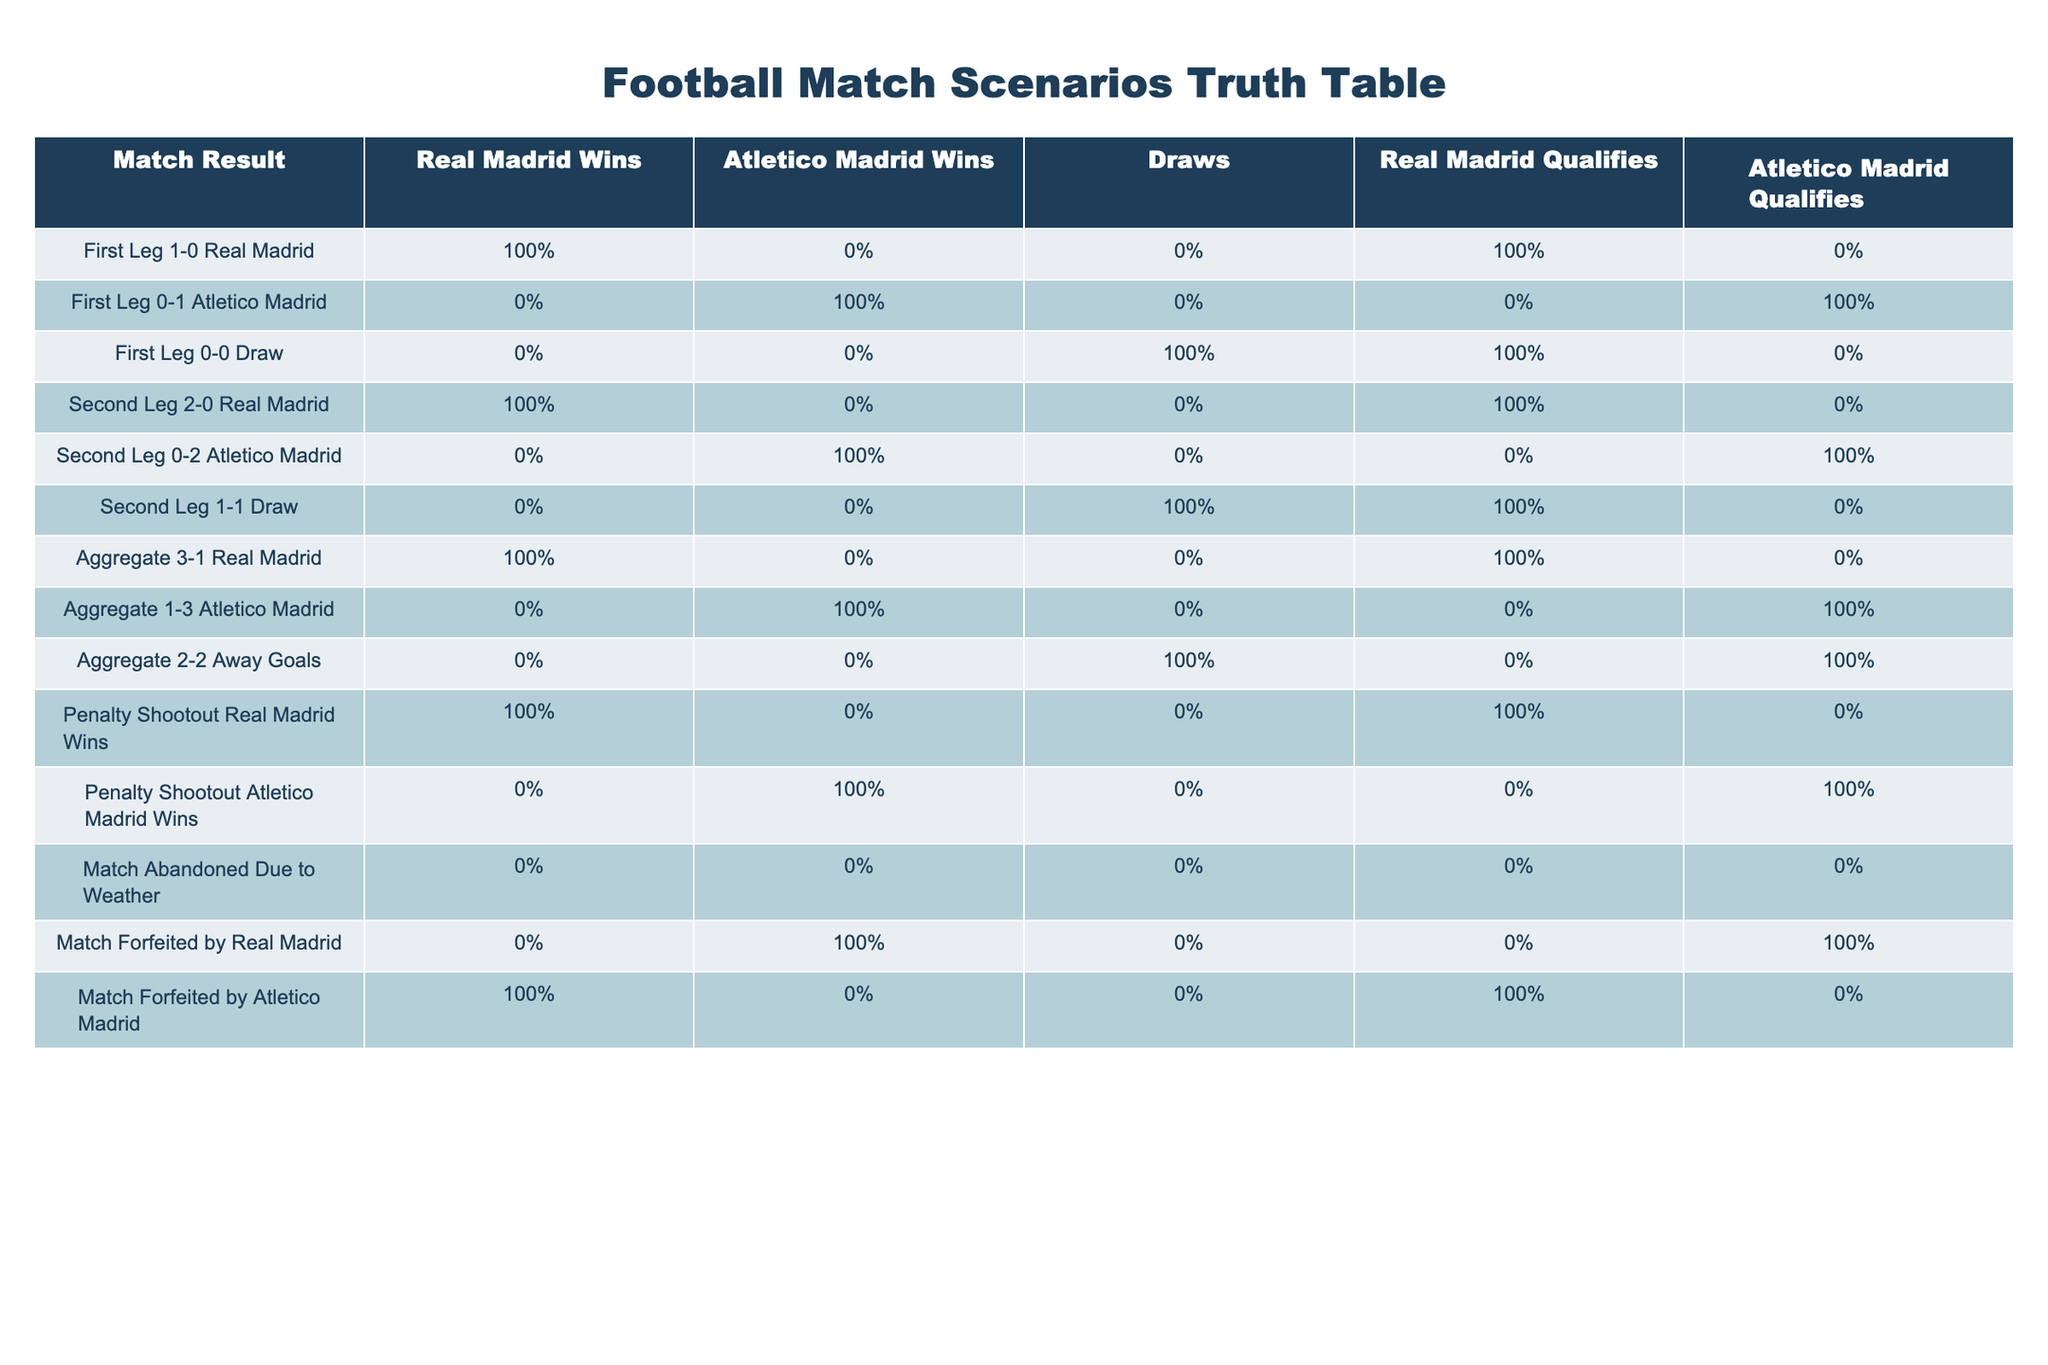What is the outcome if the first leg ends in a 0-0 draw? The second column of the row for "First Leg 0-0 Draw" shows FALSE for Real Madrid Wins and Atletico Madrid Wins, indicating no winner. The Draw column shows TRUE, confirming that the match ended in a draw. In the qualification section, Real Madrid qualifies is TRUE and Atletico Madrid qualifies is FALSE, meaning Real Madrid would still qualify.
Answer: Real Madrid qualifies How many match scenarios lead to Atletico Madrid winning the match? By reviewing the table, there are three scenarios where Atletico Madrid Wins is TRUE: "First Leg 0-1 Atletico Madrid," "Second Leg 0-2 Atletico Madrid," and "Aggregate 1-3 Atletico Madrid." This indicates there are three distinct scenarios where Atletico wins.
Answer: 3 Is there any scenario where a match is abandoned due to weather? Checking the row "Match Abandoned Due to Weather," we see that both Real Madrid Wins and Atletico Madrid Wins columns have FALSE and the Draw column also shows FALSE. Therefore, this scenario confirms that if a match is abandoned, there is no determined winner.
Answer: Yes What is the aggregate match result if both legs end in a draw (1-1)? In the table, referring to the rows for "Second Leg 1-1 Draw" and "First Leg 1-1 Draw," we sum both legs: 1-1 in the first leg and 1-1 in the second leg results in an aggregate of 2-2. Seaing that the Away Goals rule is involved, the result should be found in the "Aggregate 2-2 Away Goals" row, which shows TRUE for Atletico Madrid qualifies, indicating they would qualify based on away goals.
Answer: Aggregate is 2-2 Away Goals In how many scenarios does Real Madrid qualify? By examining the table, Real Madrid qualifies is TRUE in six scenarios: "First Leg 1-0 Real Madrid," "Second Leg 2-0 Real Madrid," "Aggregate 3-1 Real Madrid," "Penalty Shootout Real Madrid Wins," and "Match Forfeited by Atletico Madrid." Hence, Real Madrid qualifies in a total of five scenarios.
Answer: 6 